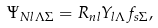Convert formula to latex. <formula><loc_0><loc_0><loc_500><loc_500>\Psi _ { N l \Lambda \Sigma } = R _ { n l } Y _ { l \Lambda } f _ { s \Sigma } ,</formula> 